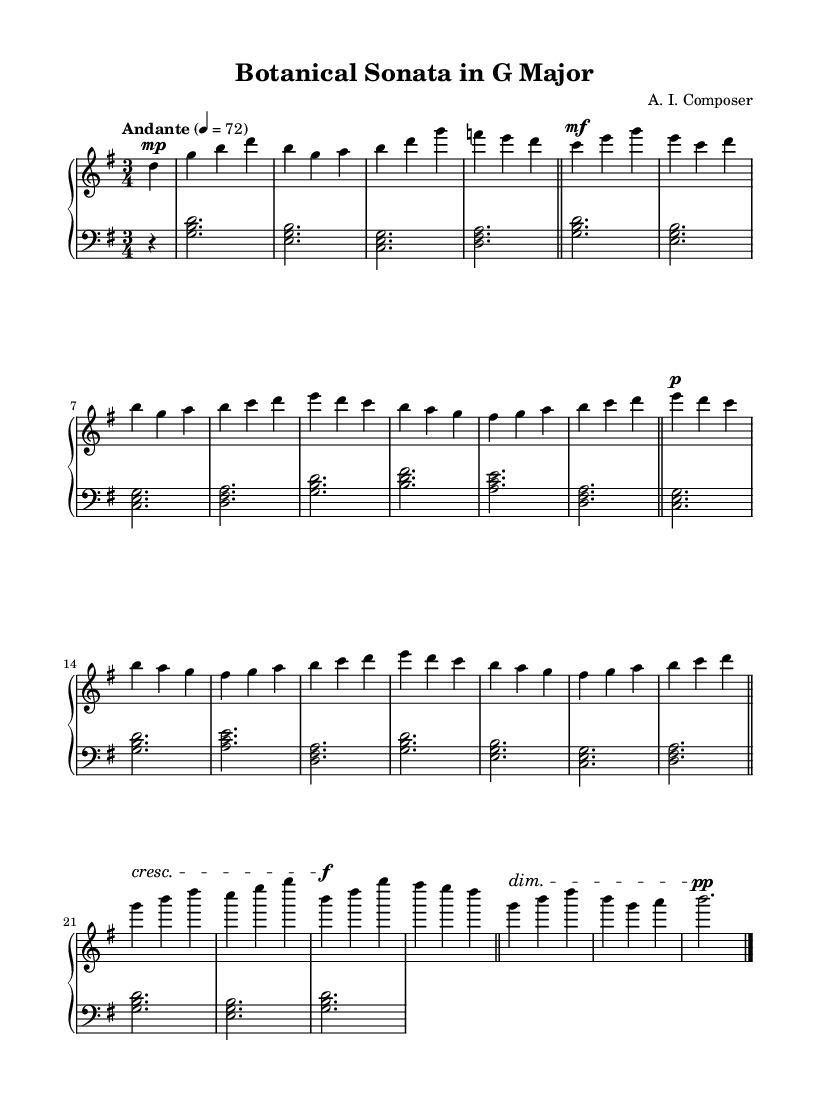What is the key signature of this music? The key signature is G major, which has one sharp (F#). This can be identified by looking at the key signature at the beginning of the staff, which shows one sharp indicating G major.
Answer: G major What is the time signature of this music? The time signature is 3/4, indicating that there are three beats per measure and the quarter note receives one beat. This is found next to the clef at the beginning of the music.
Answer: 3/4 What is the tempo marking of this music? The tempo marking is "Andante," which suggests a moderately slow tempo. This is indicated in the score above the staff where the tempo is specified along with the metronome marking.
Answer: Andante How many measures are in the development section? The development section consists of three measures, identifiable by looking for sections where the music material is varied or developed, often indicated by a different style or texture in the notation.
Answer: 3 What is the dynamic marking at the beginning of the theme A? The dynamic marking at the beginning of theme A is "mf," which stands for mezzo-forte, meaning moderately loud. This is found marked above the first note in the theme A section.
Answer: mf Which section has the coda in the music? The coda is located after the abbreviated development and recapitulation section, specifically marked at the end of the piece to signify the final section of the music. This can be recognized as it is generally a separate part at the end with a distinct musical element.
Answer: Coda 